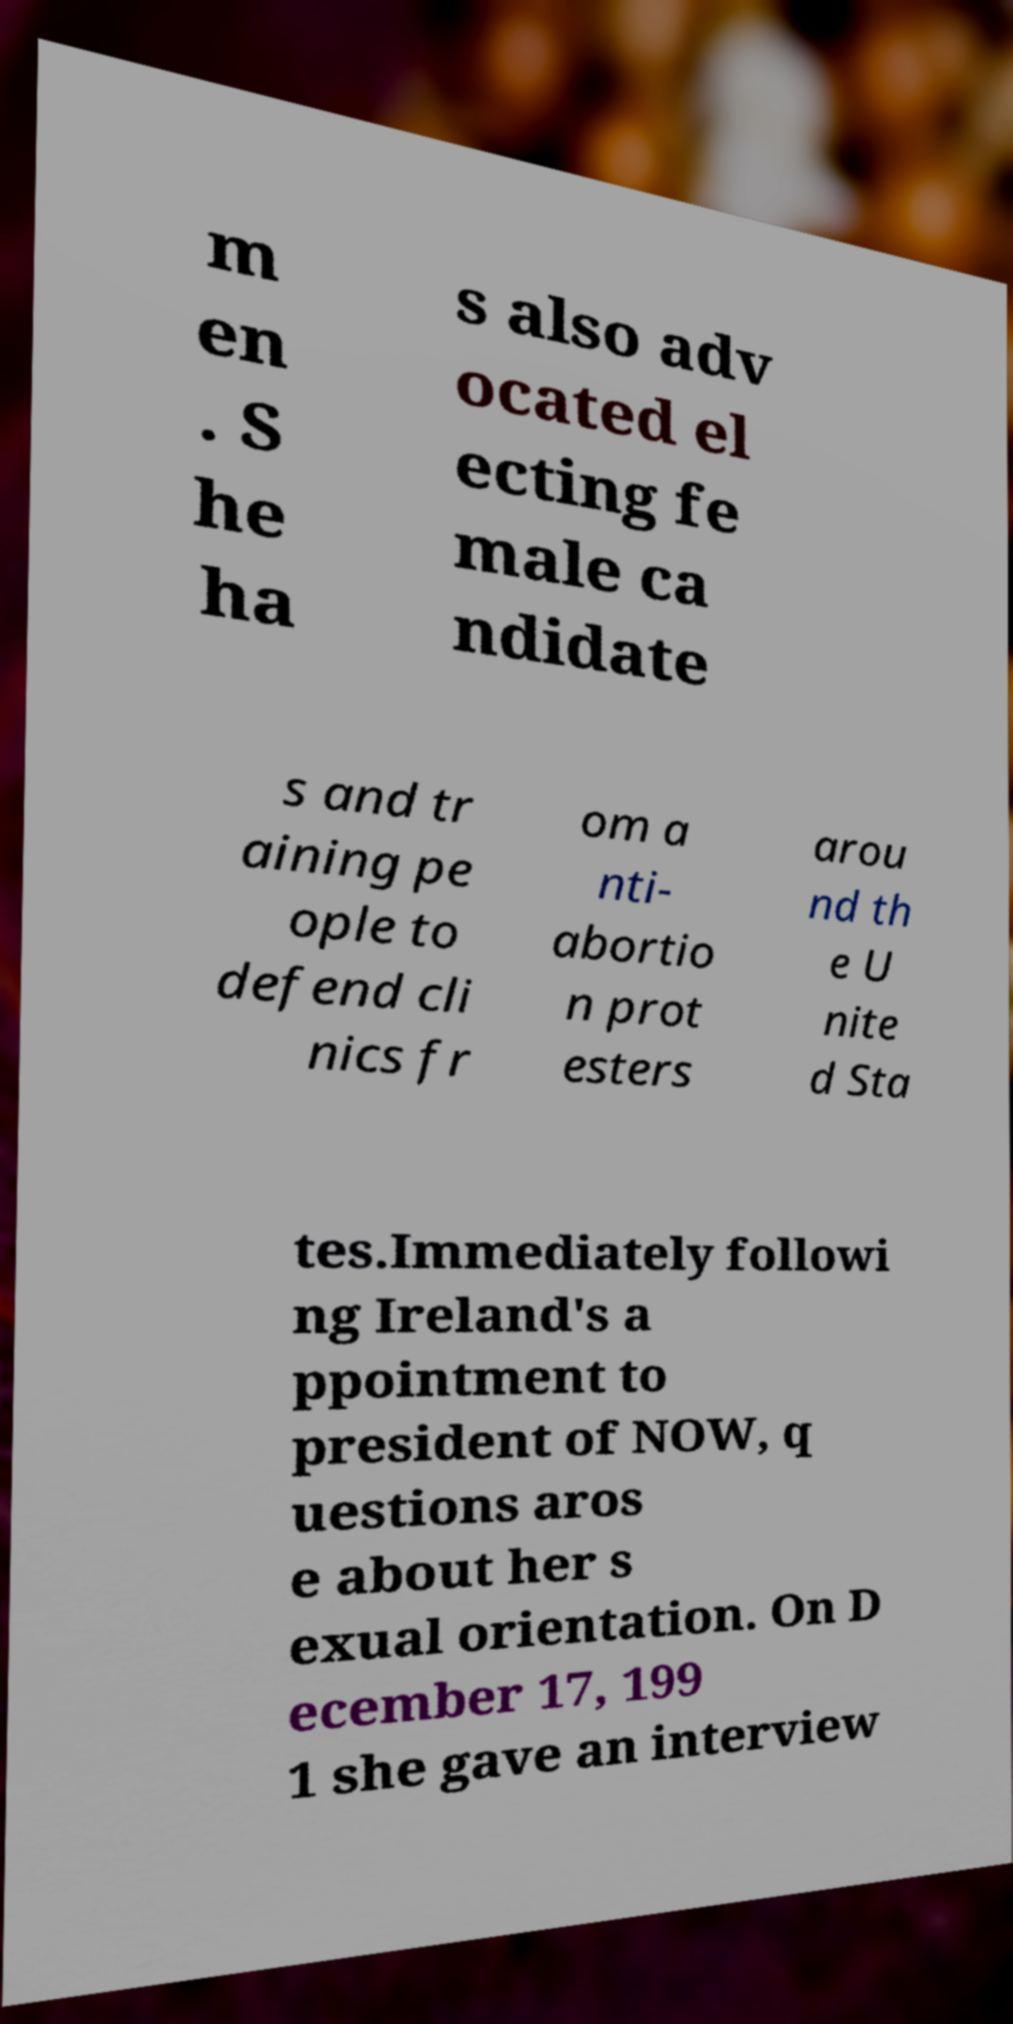Can you read and provide the text displayed in the image?This photo seems to have some interesting text. Can you extract and type it out for me? m en . S he ha s also adv ocated el ecting fe male ca ndidate s and tr aining pe ople to defend cli nics fr om a nti- abortio n prot esters arou nd th e U nite d Sta tes.Immediately followi ng Ireland's a ppointment to president of NOW, q uestions aros e about her s exual orientation. On D ecember 17, 199 1 she gave an interview 